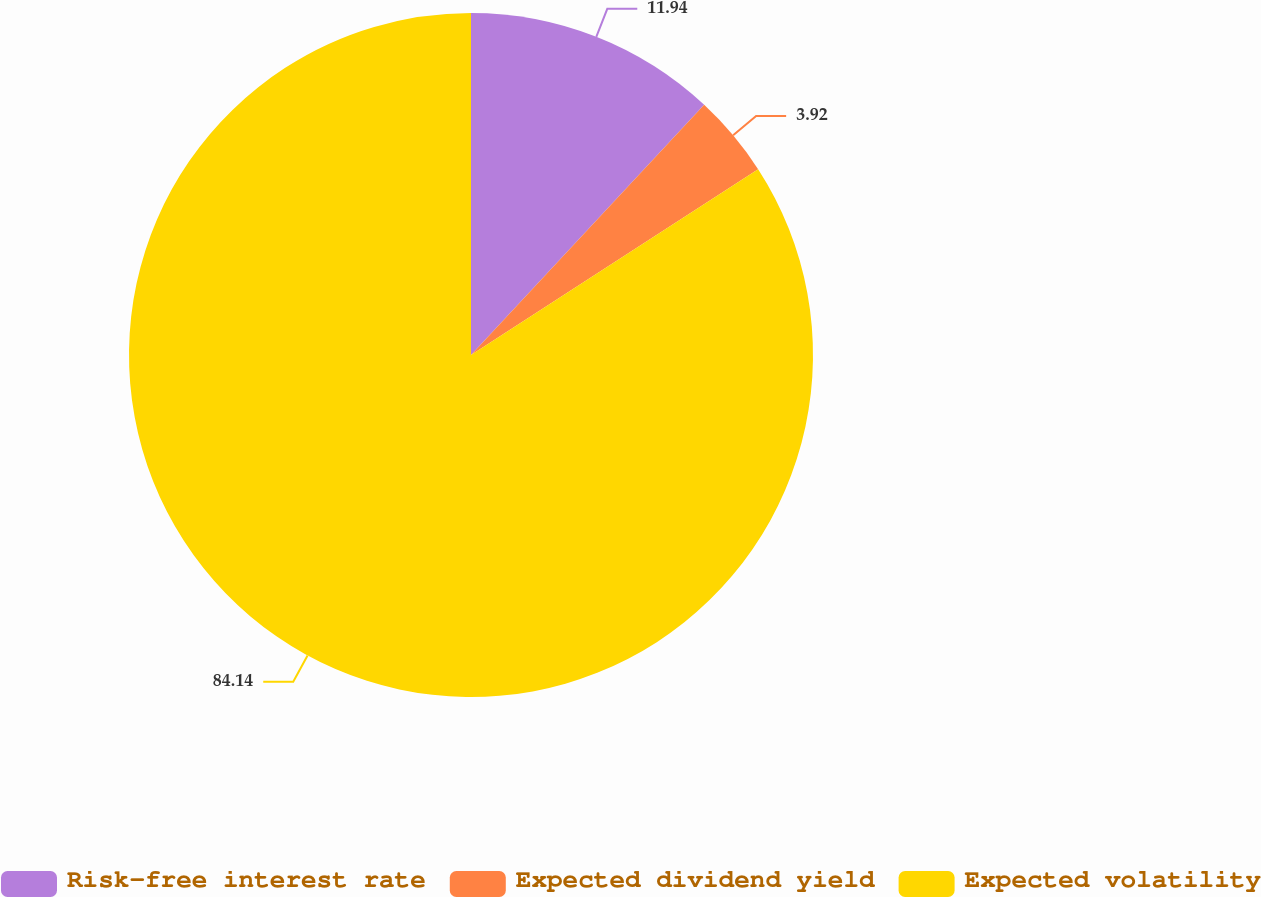Convert chart to OTSL. <chart><loc_0><loc_0><loc_500><loc_500><pie_chart><fcel>Risk-free interest rate<fcel>Expected dividend yield<fcel>Expected volatility<nl><fcel>11.94%<fcel>3.92%<fcel>84.14%<nl></chart> 